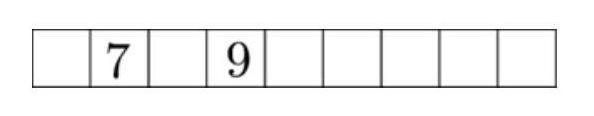The numbers from 1 to 9 are to be distributed to the nine squares in the diagram according to the following rules: There is to be one number in each square. The sum of three adjacent numbers is always a multiple of 3 . The numbers 7 and 9 are already written in. How many ways are there to insert the remaining numbers? The arrangement of numbers requires careful consideration of their properties relative to the sum rule. To find the ways to fill the remaining squares, we must ensure that the sum of any three adjacent squares is a multiple of 3. One approach is to start by testing possible placements for the next adjacent squares to '7' and '9' and continue systematically to ensure each sum is valid. The calculations might involve understanding sequences and multiples of 3, perhaps using backtracking to find all potential configurations. For a precise calculation, this often requires a programmatic approach or a detailed, structured manual approach. The answer '24 ways' suggests that multiple configurations were tested following these rules. 